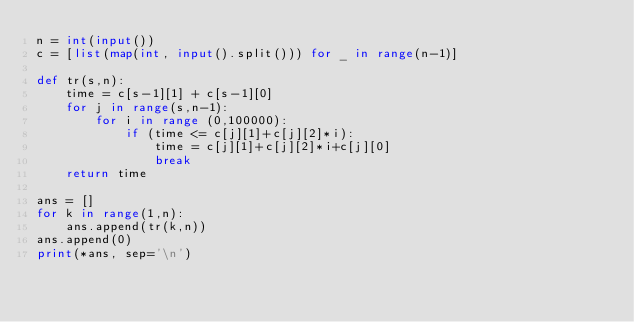<code> <loc_0><loc_0><loc_500><loc_500><_Python_>n = int(input())
c = [list(map(int, input().split())) for _ in range(n-1)]

def tr(s,n):
    time = c[s-1][1] + c[s-1][0]
    for j in range(s,n-1):
        for i in range (0,100000):
            if (time <= c[j][1]+c[j][2]*i):
                time = c[j][1]+c[j][2]*i+c[j][0]
                break
    return time

ans = []
for k in range(1,n):
    ans.append(tr(k,n))
ans.append(0)
print(*ans, sep='\n')</code> 